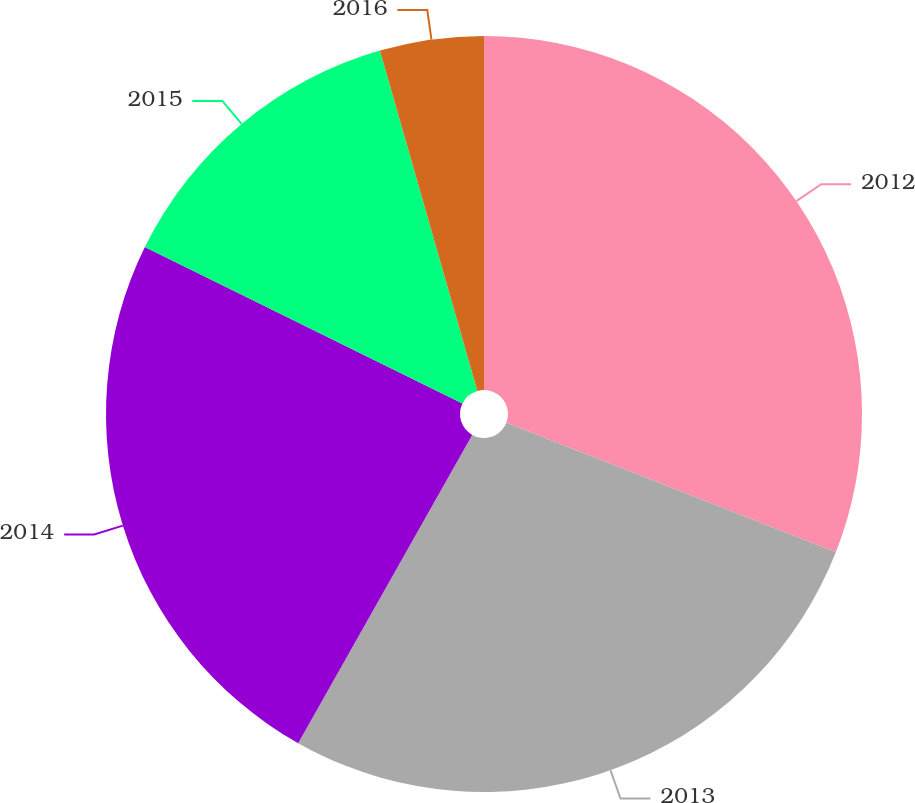Convert chart to OTSL. <chart><loc_0><loc_0><loc_500><loc_500><pie_chart><fcel>2012<fcel>2013<fcel>2014<fcel>2015<fcel>2016<nl><fcel>30.96%<fcel>27.22%<fcel>24.1%<fcel>13.28%<fcel>4.44%<nl></chart> 